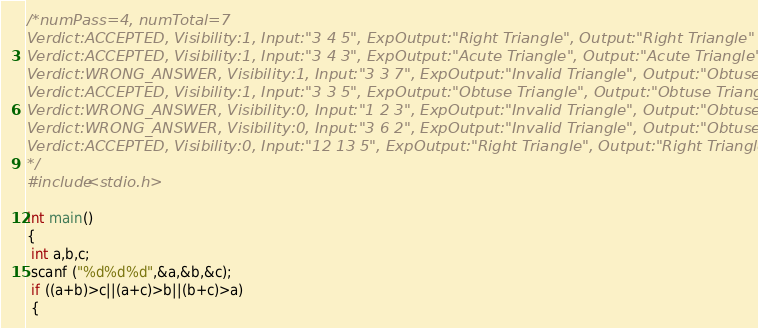Convert code to text. <code><loc_0><loc_0><loc_500><loc_500><_C_>/*numPass=4, numTotal=7
Verdict:ACCEPTED, Visibility:1, Input:"3 4 5", ExpOutput:"Right Triangle", Output:"Right Triangle"
Verdict:ACCEPTED, Visibility:1, Input:"3 4 3", ExpOutput:"Acute Triangle", Output:"Acute Triangle"
Verdict:WRONG_ANSWER, Visibility:1, Input:"3 3 7", ExpOutput:"Invalid Triangle", Output:"Obtuse Triangle"
Verdict:ACCEPTED, Visibility:1, Input:"3 3 5", ExpOutput:"Obtuse Triangle", Output:"Obtuse Triangle"
Verdict:WRONG_ANSWER, Visibility:0, Input:"1 2 3", ExpOutput:"Invalid Triangle", Output:"Obtuse Triangle"
Verdict:WRONG_ANSWER, Visibility:0, Input:"3 6 2", ExpOutput:"Invalid Triangle", Output:"Obtuse Triangle"
Verdict:ACCEPTED, Visibility:0, Input:"12 13 5", ExpOutput:"Right Triangle", Output:"Right Triangle"
*/
#include<stdio.h>

int main()
{
 int a,b,c;
 scanf ("%d%d%d",&a,&b,&c);
 if ((a+b)>c||(a+c)>b||(b+c)>a)
 {</code> 